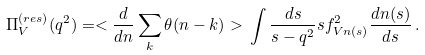Convert formula to latex. <formula><loc_0><loc_0><loc_500><loc_500>\Pi _ { V } ^ { ( r e s ) } ( q ^ { 2 } ) = < \frac { d } { d n } \sum _ { k } \theta ( n - k ) > \, \int \frac { d s } { s - q ^ { 2 } } s f ^ { 2 } _ { V n ( s ) } \frac { d n ( s ) } { d s } \, .</formula> 